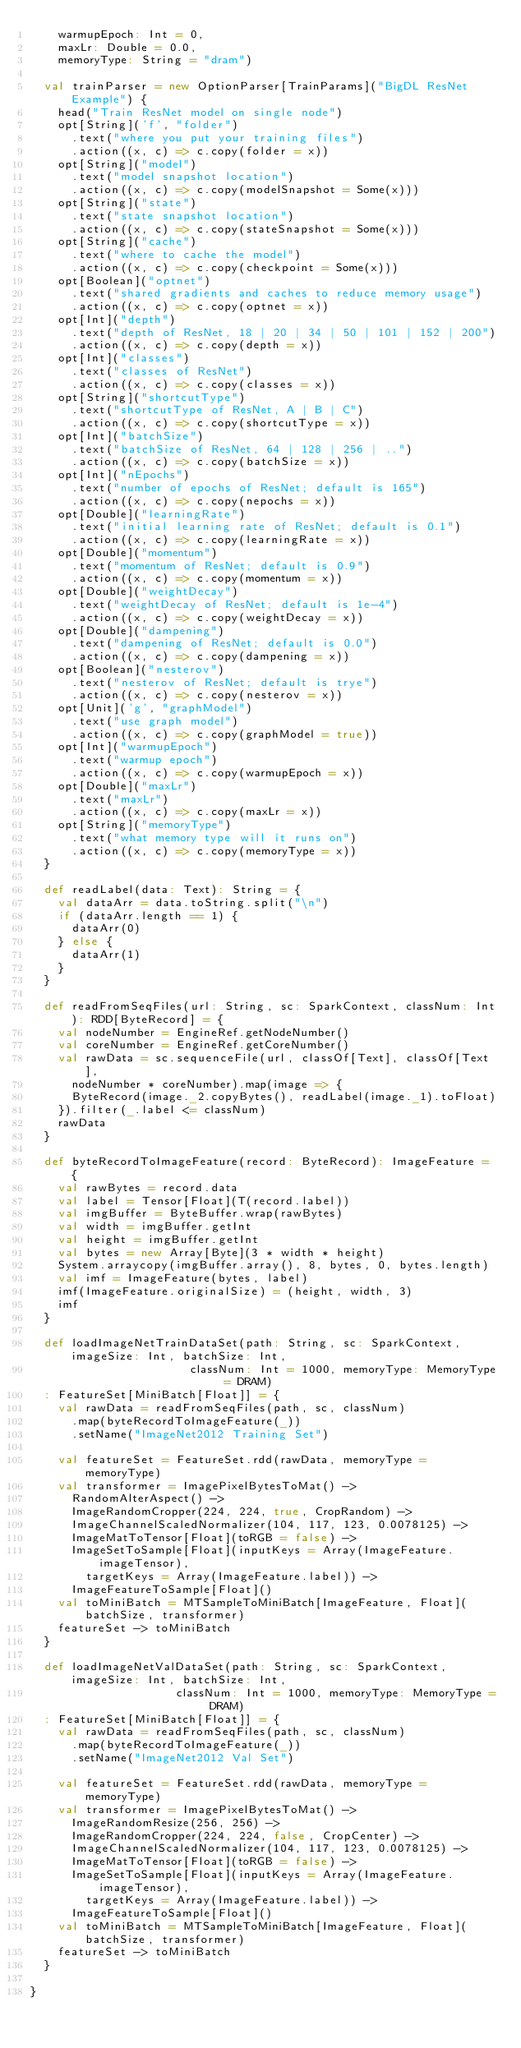<code> <loc_0><loc_0><loc_500><loc_500><_Scala_>    warmupEpoch: Int = 0,
    maxLr: Double = 0.0,
    memoryType: String = "dram")

  val trainParser = new OptionParser[TrainParams]("BigDL ResNet Example") {
    head("Train ResNet model on single node")
    opt[String]('f', "folder")
      .text("where you put your training files")
      .action((x, c) => c.copy(folder = x))
    opt[String]("model")
      .text("model snapshot location")
      .action((x, c) => c.copy(modelSnapshot = Some(x)))
    opt[String]("state")
      .text("state snapshot location")
      .action((x, c) => c.copy(stateSnapshot = Some(x)))
    opt[String]("cache")
      .text("where to cache the model")
      .action((x, c) => c.copy(checkpoint = Some(x)))
    opt[Boolean]("optnet")
      .text("shared gradients and caches to reduce memory usage")
      .action((x, c) => c.copy(optnet = x))
    opt[Int]("depth")
      .text("depth of ResNet, 18 | 20 | 34 | 50 | 101 | 152 | 200")
      .action((x, c) => c.copy(depth = x))
    opt[Int]("classes")
      .text("classes of ResNet")
      .action((x, c) => c.copy(classes = x))
    opt[String]("shortcutType")
      .text("shortcutType of ResNet, A | B | C")
      .action((x, c) => c.copy(shortcutType = x))
    opt[Int]("batchSize")
      .text("batchSize of ResNet, 64 | 128 | 256 | ..")
      .action((x, c) => c.copy(batchSize = x))
    opt[Int]("nEpochs")
      .text("number of epochs of ResNet; default is 165")
      .action((x, c) => c.copy(nepochs = x))
    opt[Double]("learningRate")
      .text("initial learning rate of ResNet; default is 0.1")
      .action((x, c) => c.copy(learningRate = x))
    opt[Double]("momentum")
      .text("momentum of ResNet; default is 0.9")
      .action((x, c) => c.copy(momentum = x))
    opt[Double]("weightDecay")
      .text("weightDecay of ResNet; default is 1e-4")
      .action((x, c) => c.copy(weightDecay = x))
    opt[Double]("dampening")
      .text("dampening of ResNet; default is 0.0")
      .action((x, c) => c.copy(dampening = x))
    opt[Boolean]("nesterov")
      .text("nesterov of ResNet; default is trye")
      .action((x, c) => c.copy(nesterov = x))
    opt[Unit]('g', "graphModel")
      .text("use graph model")
      .action((x, c) => c.copy(graphModel = true))
    opt[Int]("warmupEpoch")
      .text("warmup epoch")
      .action((x, c) => c.copy(warmupEpoch = x))
    opt[Double]("maxLr")
      .text("maxLr")
      .action((x, c) => c.copy(maxLr = x))
    opt[String]("memoryType")
      .text("what memory type will it runs on")
      .action((x, c) => c.copy(memoryType = x))
  }

  def readLabel(data: Text): String = {
    val dataArr = data.toString.split("\n")
    if (dataArr.length == 1) {
      dataArr(0)
    } else {
      dataArr(1)
    }
  }

  def readFromSeqFiles(url: String, sc: SparkContext, classNum: Int): RDD[ByteRecord] = {
    val nodeNumber = EngineRef.getNodeNumber()
    val coreNumber = EngineRef.getCoreNumber()
    val rawData = sc.sequenceFile(url, classOf[Text], classOf[Text],
      nodeNumber * coreNumber).map(image => {
      ByteRecord(image._2.copyBytes(), readLabel(image._1).toFloat)
    }).filter(_.label <= classNum)
    rawData
  }

  def byteRecordToImageFeature(record: ByteRecord): ImageFeature = {
    val rawBytes = record.data
    val label = Tensor[Float](T(record.label))
    val imgBuffer = ByteBuffer.wrap(rawBytes)
    val width = imgBuffer.getInt
    val height = imgBuffer.getInt
    val bytes = new Array[Byte](3 * width * height)
    System.arraycopy(imgBuffer.array(), 8, bytes, 0, bytes.length)
    val imf = ImageFeature(bytes, label)
    imf(ImageFeature.originalSize) = (height, width, 3)
    imf
  }

  def loadImageNetTrainDataSet(path: String, sc: SparkContext, imageSize: Int, batchSize: Int,
                       classNum: Int = 1000, memoryType: MemoryType = DRAM)
  : FeatureSet[MiniBatch[Float]] = {
    val rawData = readFromSeqFiles(path, sc, classNum)
      .map(byteRecordToImageFeature(_))
      .setName("ImageNet2012 Training Set")

    val featureSet = FeatureSet.rdd(rawData, memoryType = memoryType)
    val transformer = ImagePixelBytesToMat() ->
      RandomAlterAspect() ->
      ImageRandomCropper(224, 224, true, CropRandom) ->
      ImageChannelScaledNormalizer(104, 117, 123, 0.0078125) ->
      ImageMatToTensor[Float](toRGB = false) ->
      ImageSetToSample[Float](inputKeys = Array(ImageFeature.imageTensor),
        targetKeys = Array(ImageFeature.label)) ->
      ImageFeatureToSample[Float]()
    val toMiniBatch = MTSampleToMiniBatch[ImageFeature, Float](batchSize, transformer)
    featureSet -> toMiniBatch
  }

  def loadImageNetValDataSet(path: String, sc: SparkContext, imageSize: Int, batchSize: Int,
                     classNum: Int = 1000, memoryType: MemoryType = DRAM)
  : FeatureSet[MiniBatch[Float]] = {
    val rawData = readFromSeqFiles(path, sc, classNum)
      .map(byteRecordToImageFeature(_))
      .setName("ImageNet2012 Val Set")

    val featureSet = FeatureSet.rdd(rawData, memoryType = memoryType)
    val transformer = ImagePixelBytesToMat() ->
      ImageRandomResize(256, 256) ->
      ImageRandomCropper(224, 224, false, CropCenter) ->
      ImageChannelScaledNormalizer(104, 117, 123, 0.0078125) ->
      ImageMatToTensor[Float](toRGB = false) ->
      ImageSetToSample[Float](inputKeys = Array(ImageFeature.imageTensor),
        targetKeys = Array(ImageFeature.label)) ->
      ImageFeatureToSample[Float]()
    val toMiniBatch = MTSampleToMiniBatch[ImageFeature, Float](batchSize, transformer)
    featureSet -> toMiniBatch
  }

}
</code> 